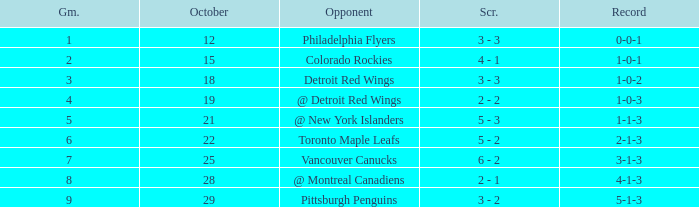Name the least game for october 21 5.0. 